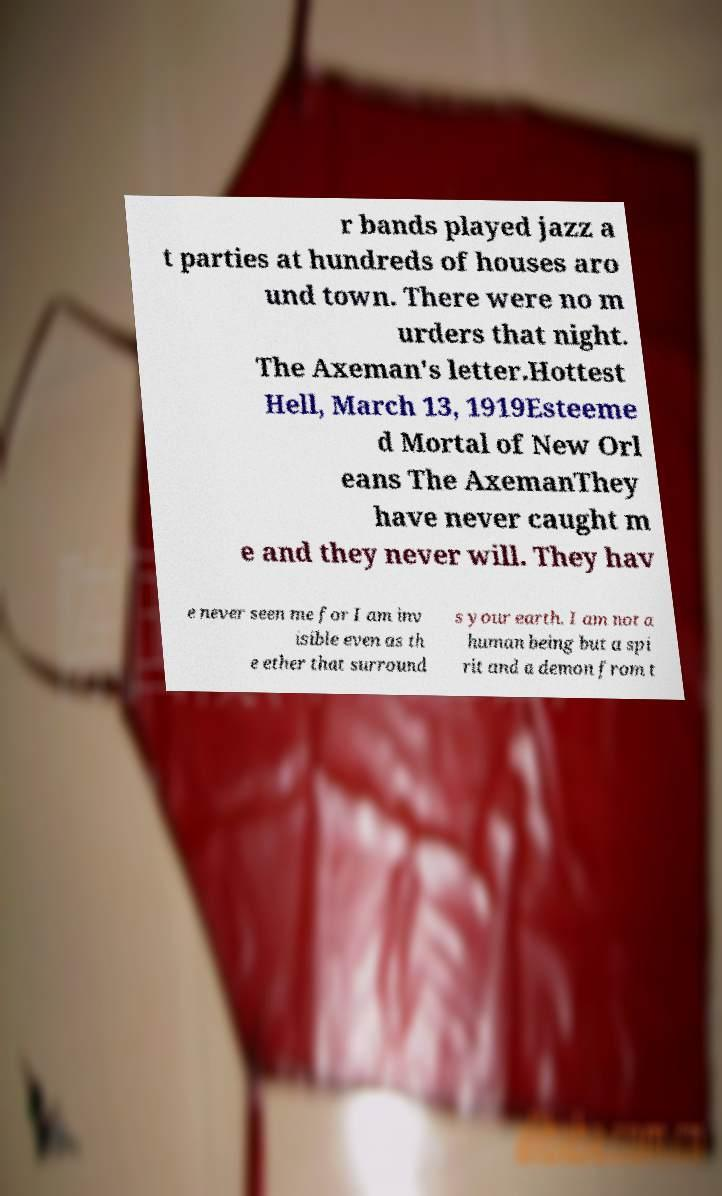Could you extract and type out the text from this image? r bands played jazz a t parties at hundreds of houses aro und town. There were no m urders that night. The Axeman's letter.Hottest Hell, March 13, 1919Esteeme d Mortal of New Orl eans The AxemanThey have never caught m e and they never will. They hav e never seen me for I am inv isible even as th e ether that surround s your earth. I am not a human being but a spi rit and a demon from t 